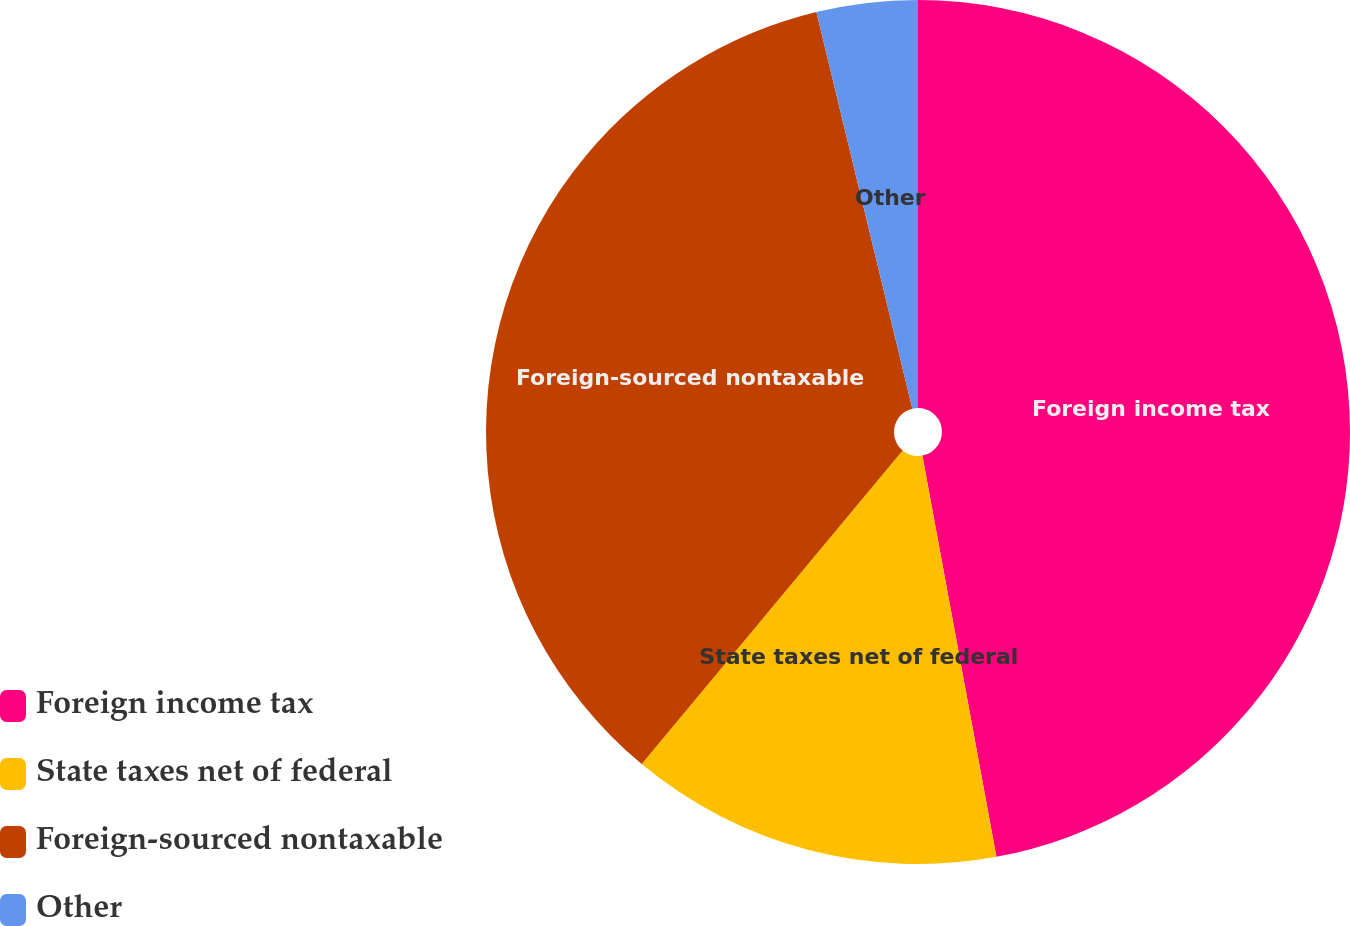<chart> <loc_0><loc_0><loc_500><loc_500><pie_chart><fcel>Foreign income tax<fcel>State taxes net of federal<fcel>Foreign-sourced nontaxable<fcel>Other<nl><fcel>47.1%<fcel>13.95%<fcel>35.18%<fcel>3.78%<nl></chart> 